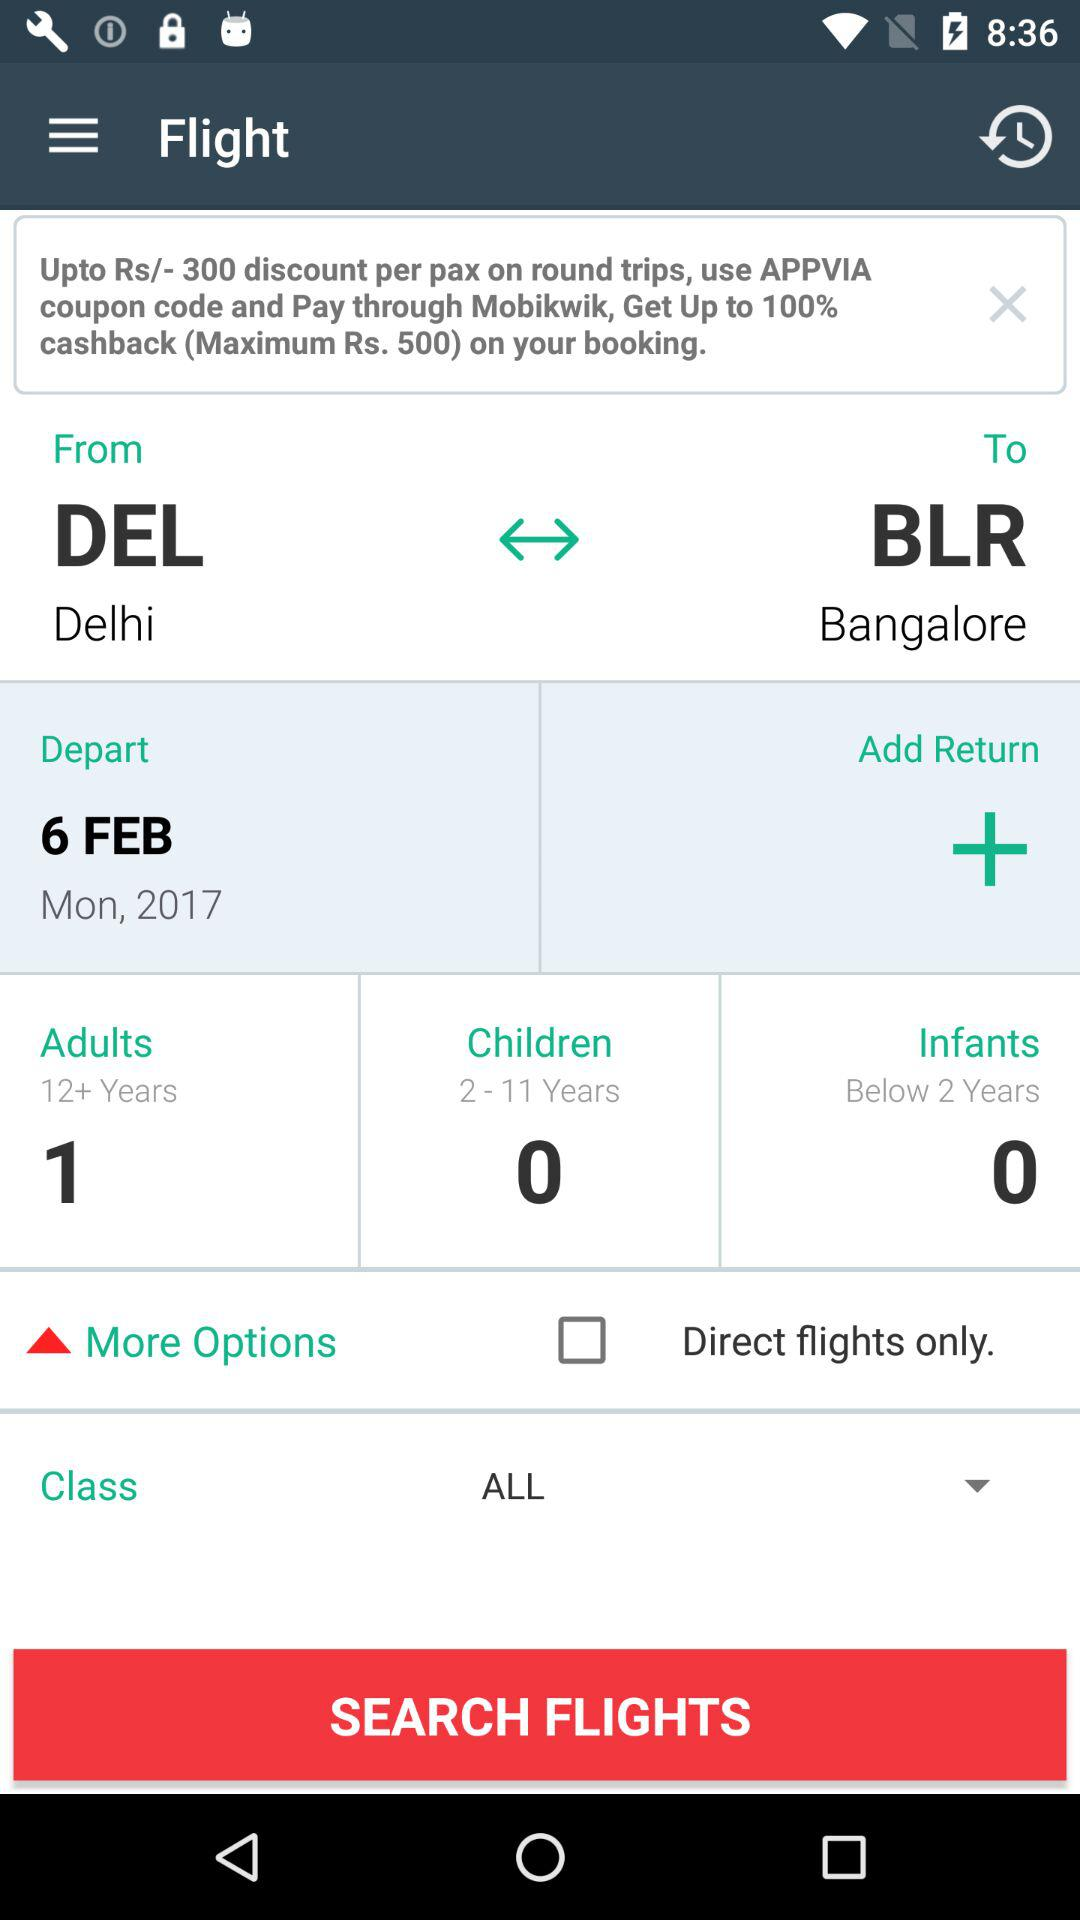How many children are there? There are 0 children. 